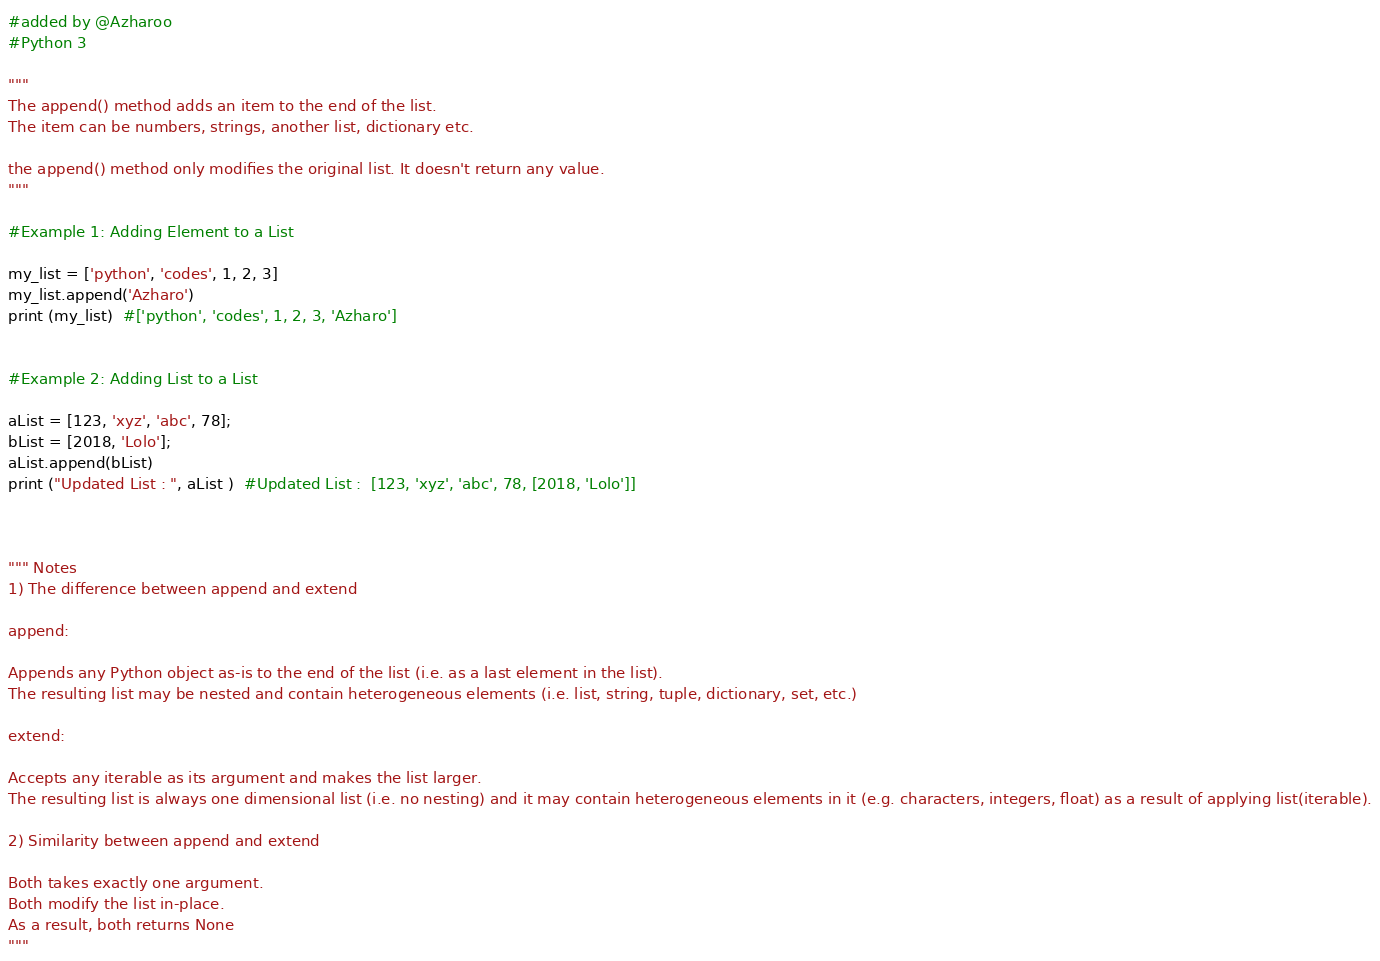<code> <loc_0><loc_0><loc_500><loc_500><_Python_>#added by @Azharoo
#Python 3

"""
The append() method adds an item to the end of the list.
The item can be numbers, strings, another list, dictionary etc.

the append() method only modifies the original list. It doesn't return any value.
"""

#Example 1: Adding Element to a List

my_list = ['python', 'codes', 1, 2, 3]
my_list.append('Azharo')
print (my_list)  #['python', 'codes', 1, 2, 3, 'Azharo']


#Example 2: Adding List to a List

aList = [123, 'xyz', 'abc', 78];
bList = [2018, 'Lolo'];
aList.append(bList)
print ("Updated List : ", aList )  #Updated List :  [123, 'xyz', 'abc', 78, [2018, 'Lolo']]



""" Notes
1) The difference between append and extend

append:

Appends any Python object as-is to the end of the list (i.e. as a last element in the list).
The resulting list may be nested and contain heterogeneous elements (i.e. list, string, tuple, dictionary, set, etc.)

extend:

Accepts any iterable as its argument and makes the list larger.
The resulting list is always one dimensional list (i.e. no nesting) and it may contain heterogeneous elements in it (e.g. characters, integers, float) as a result of applying list(iterable).

2) Similarity between append and extend

Both takes exactly one argument.
Both modify the list in-place.
As a result, both returns None
"""</code> 